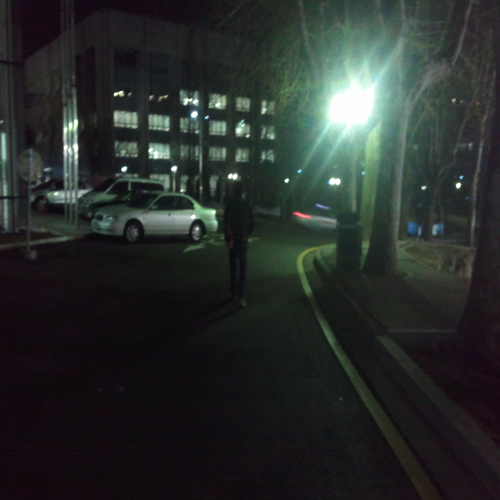What can you infer about the location depicted in this image? From the structures in the background and the paved area, it seems to be an urban environment. The cars and the building lights suggest this photo was taken in a business district or near office buildings. Given the time of day and lack of activity, it could be after work hours or a less busy area of the city. 